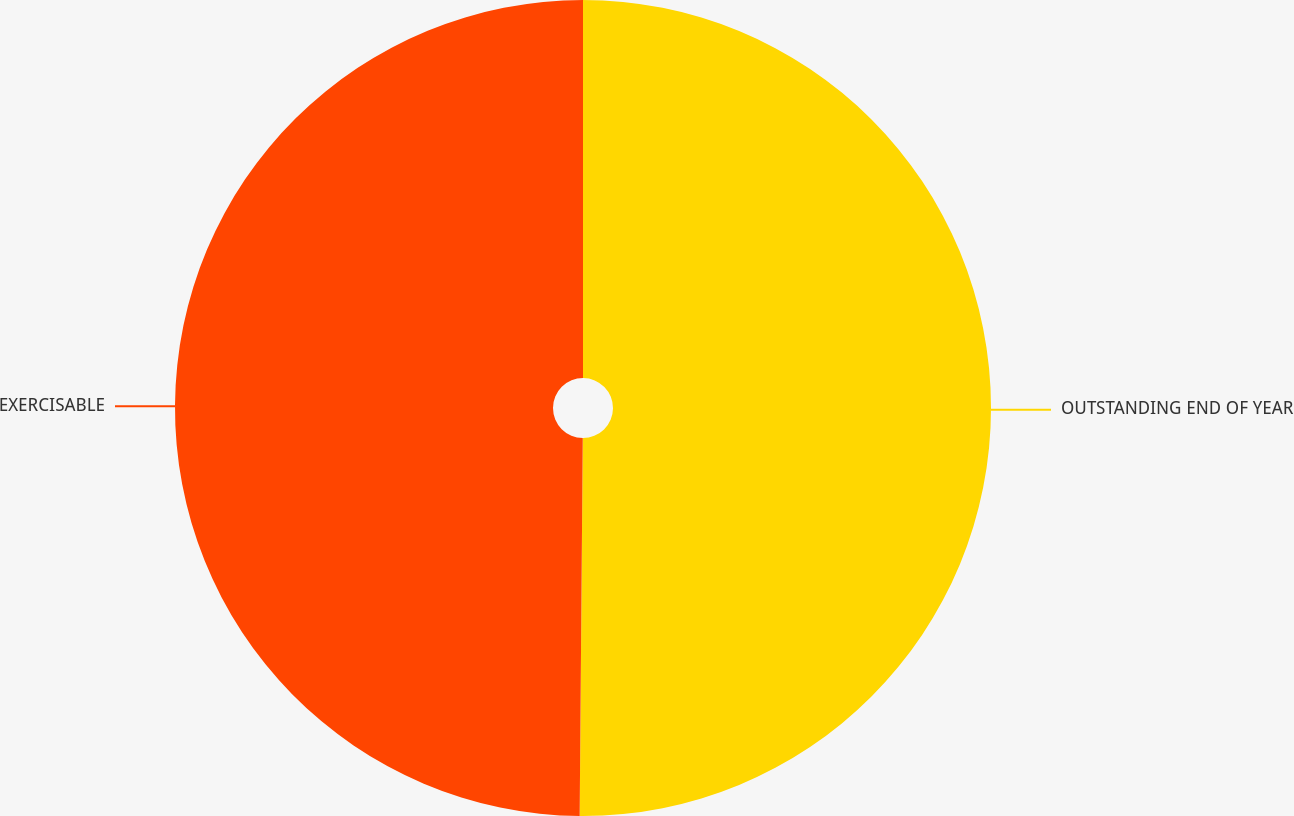Convert chart. <chart><loc_0><loc_0><loc_500><loc_500><pie_chart><fcel>OUTSTANDING END OF YEAR<fcel>EXERCISABLE<nl><fcel>50.13%<fcel>49.87%<nl></chart> 